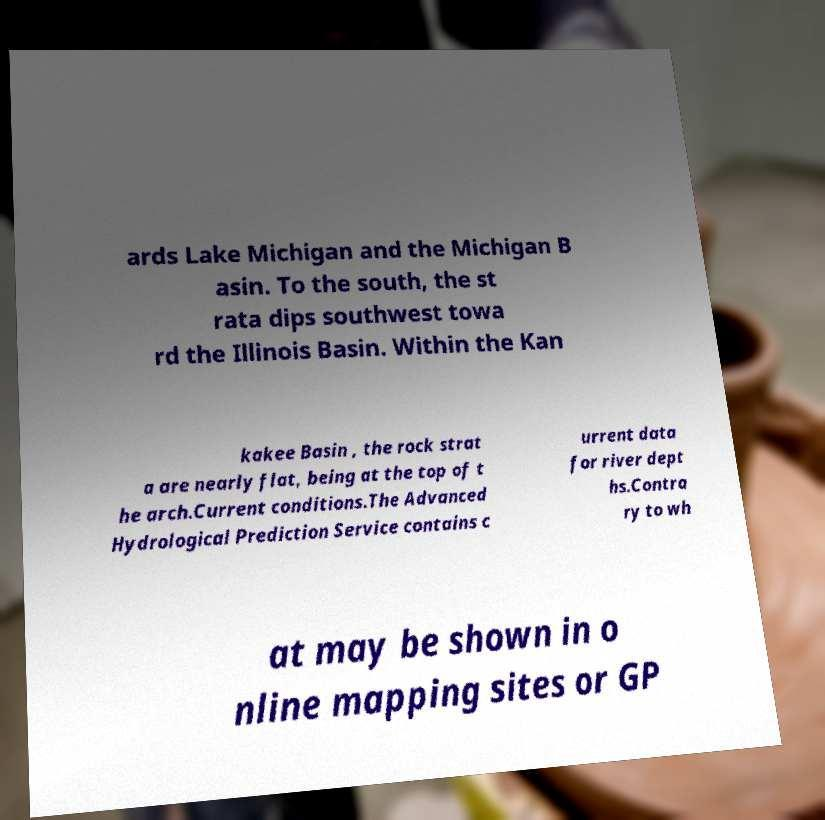There's text embedded in this image that I need extracted. Can you transcribe it verbatim? ards Lake Michigan and the Michigan B asin. To the south, the st rata dips southwest towa rd the Illinois Basin. Within the Kan kakee Basin , the rock strat a are nearly flat, being at the top of t he arch.Current conditions.The Advanced Hydrological Prediction Service contains c urrent data for river dept hs.Contra ry to wh at may be shown in o nline mapping sites or GP 